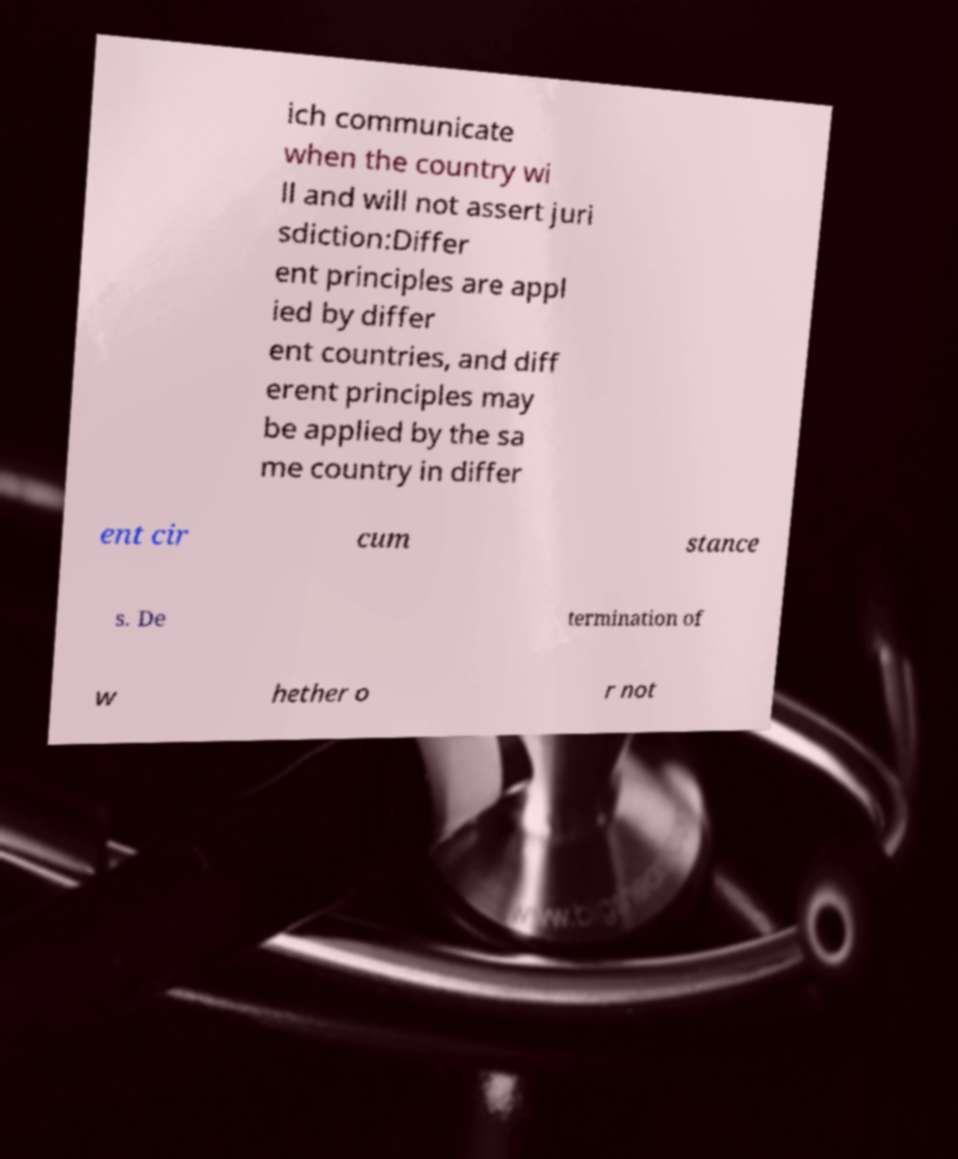Can you read and provide the text displayed in the image?This photo seems to have some interesting text. Can you extract and type it out for me? ich communicate when the country wi ll and will not assert juri sdiction:Differ ent principles are appl ied by differ ent countries, and diff erent principles may be applied by the sa me country in differ ent cir cum stance s. De termination of w hether o r not 